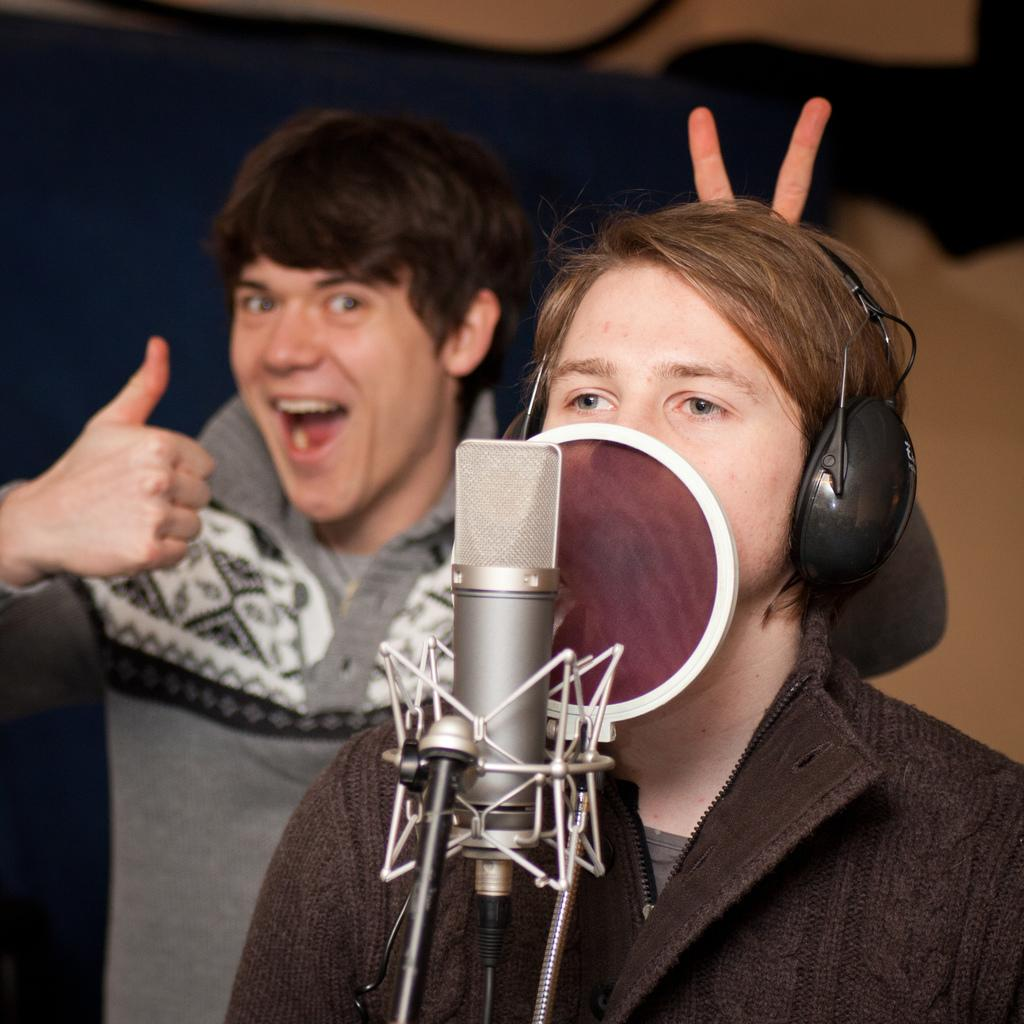How many people are in the image? There are persons standing in the image. Can you describe the attire of one of the persons? One person is wearing headphones. What object is present in the foreground of the image? There is a microphone on a stand in the foreground of the image. What color is the pump on the person's toe in the image? There is no pump or toe visible in the image; the person is wearing headphones, and no footwear is mentioned. 